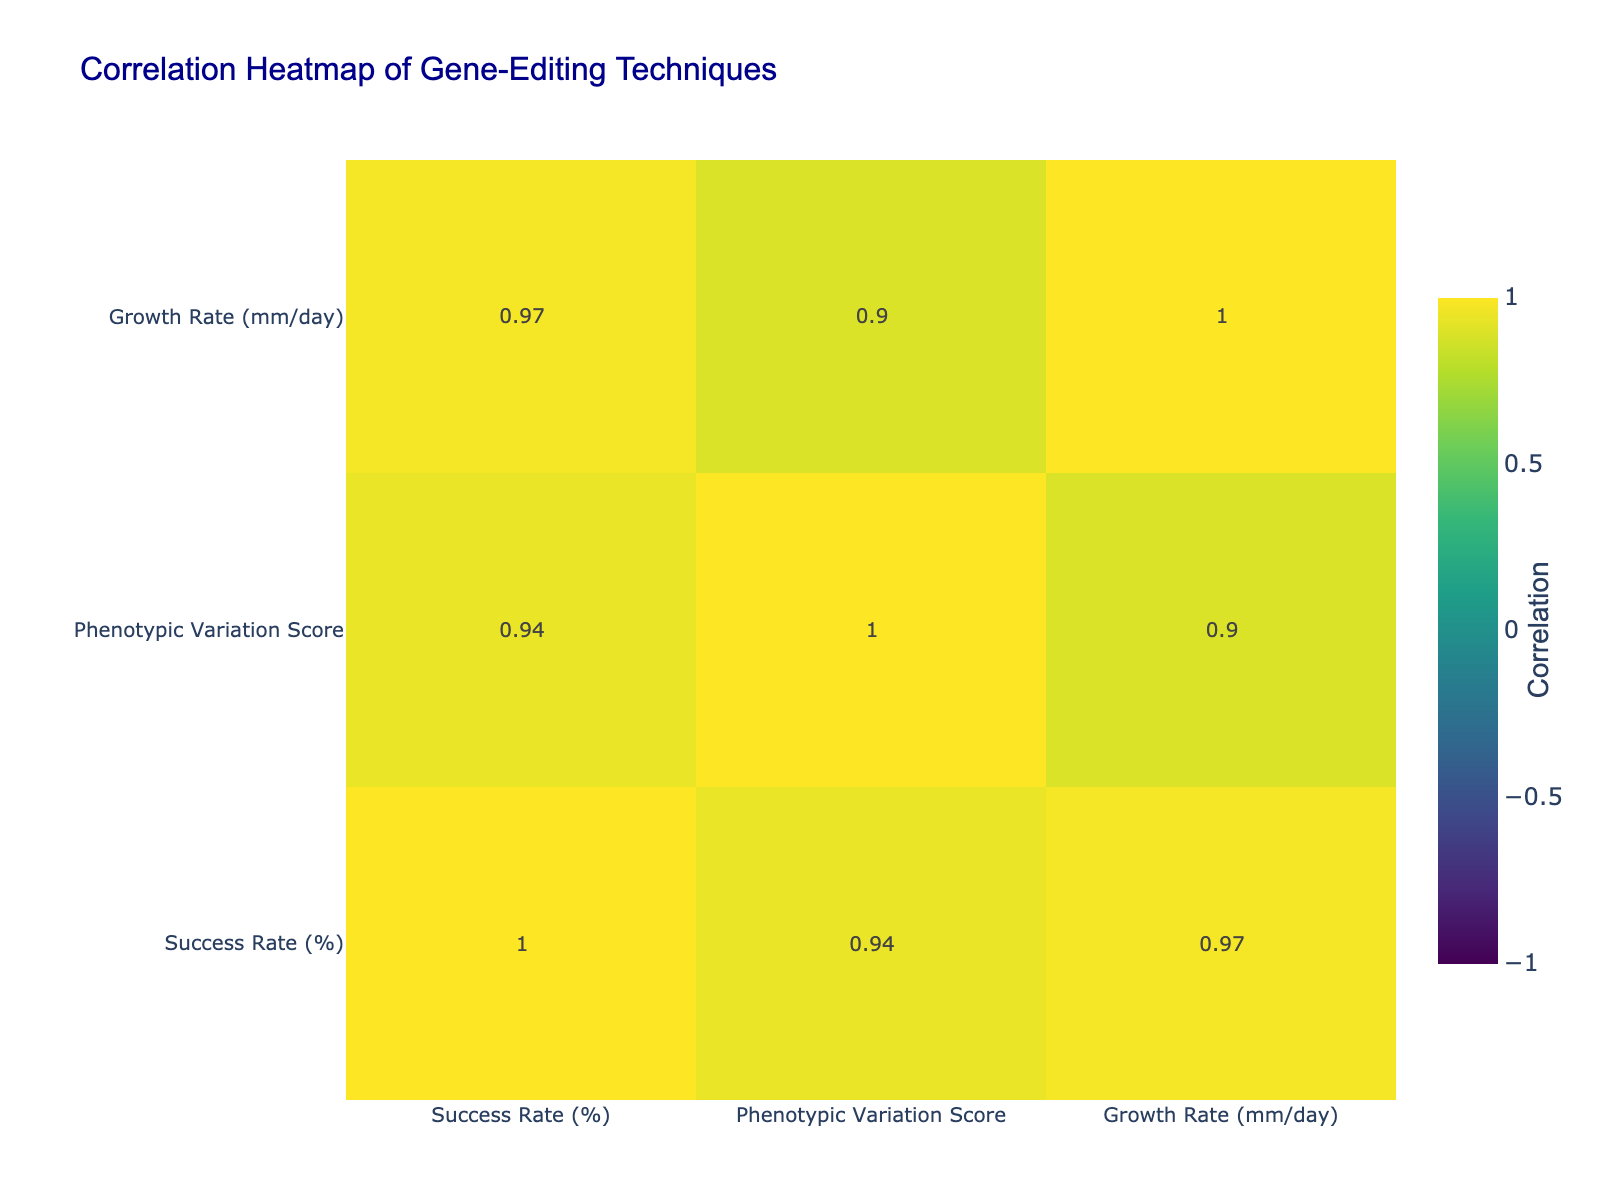What is the success rate of CRISPR-Cas9? According to the table, the success rate for CRISPR-Cas9 is listed directly next to the technique name, which shows it as 85%.
Answer: 85% What is the phenotypic variation score for Prime Editing? The phenotypic variation score for Prime Editing can be found in the corresponding row under this technique, indicating a score of 5.2.
Answer: 5.2 Which gene-editing technique has the highest growth rate? By comparing the growth rates of all techniques, Prime Editing has the highest value at 2.5 mm/day, which is the highest across the table.
Answer: Prime Editing Is the Mendelian inheritance ratio for Base Editing 3:1? Looking at the Mendelian inheritance ratio for Base Editing in the corresponding row, it shows 1:1, not 3:1. Hence, the statement is false.
Answer: No What is the average success rate of all listed techniques? First, we add up the success rates: 85 + 78 + 72 + 90 + 88 + 92 + 67 = 552. There are 7 techniques, so we divide 552 by 7, which gives approximately 78.86.
Answer: 78.86 Which technique has the lowest phenotypic variation score, and what is that score? By examining the phenotypic variation scores, RNA Interference shows the lowest score at 3.5.
Answer: RNA Interference, 3.5 Are there any techniques with a success rate below 75%? By checking the success rates in the table, RNA Interference has a success rate of 67%, which confirms the presence of techniques below this threshold.
Answer: Yes If we consider the growth rates, is there a correlation between growth rate and success rate? While examining the table numerically, we can observe that the highest growth rate (2.5 mm/day) corresponds with the highest success rate (92%). However, we will need to analyze pairs deeper across multiple techniques to determine if it's truly a consistent correlation overall.
Answer: Yes 